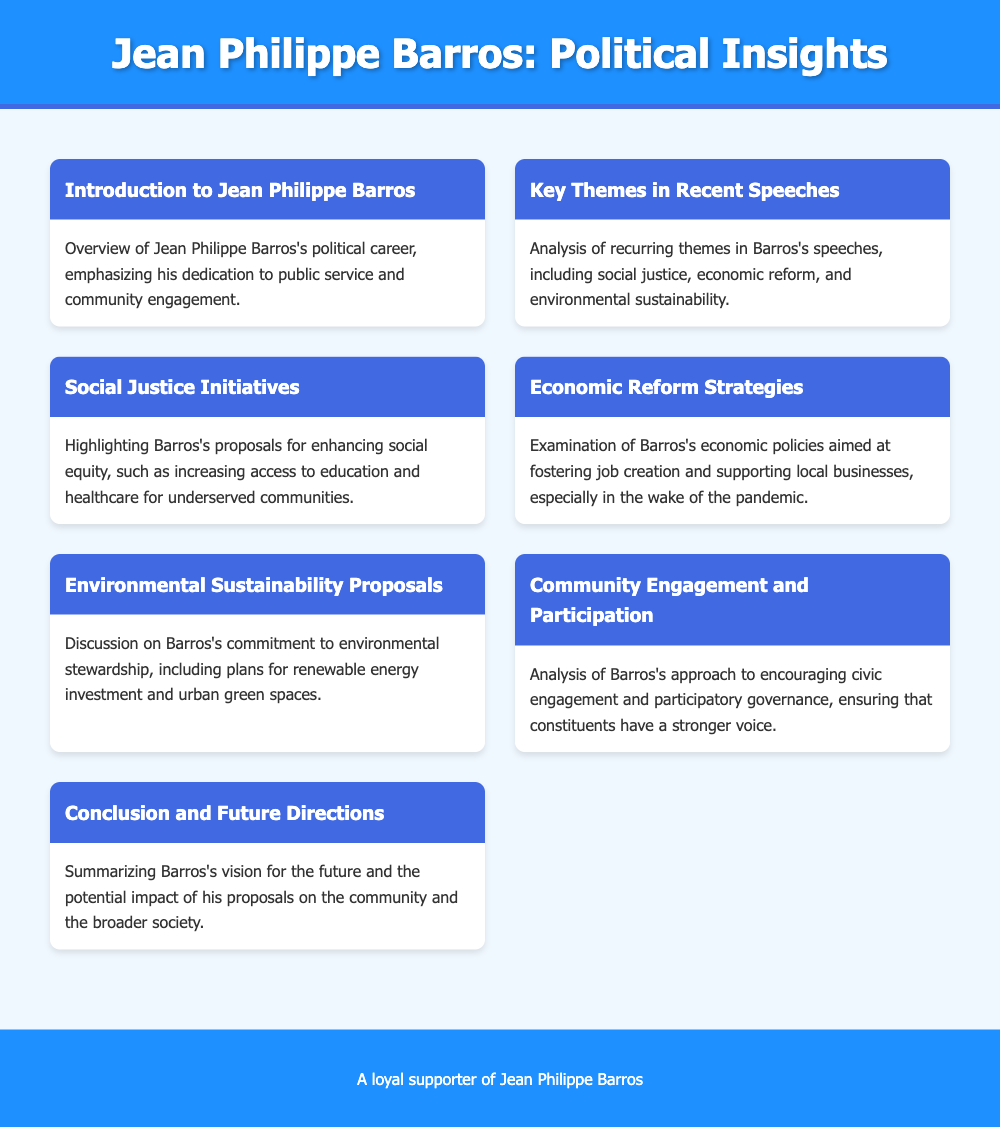What are the key themes in Barros's speeches? The document lists recurring themes such as social justice, economic reform, and environmental sustainability.
Answer: Social justice, economic reform, and environmental sustainability What does Barros propose for social equity? The document highlights proposals for increasing access to education and healthcare for underserved communities.
Answer: Increasing access to education and healthcare What is Barros's approach to community engagement? The document discusses Barros's strategies for encouraging civic engagement and participatory governance.
Answer: Encouraging civic engagement and participatory governance What are Barros's economic policies aimed at? The document examines Barros's economic policies focusing on job creation and supporting local businesses.
Answer: Job creation and supporting local businesses What future vision does Barros have? The document summarizes Barros's vision for the future and the impact of his proposals on the community.
Answer: Impact of his proposals on the community How does Barros plan to support environmental sustainability? The document mentions plans for renewable energy investment and urban green spaces as part of Barros's commitment.
Answer: Renewable energy investment and urban green spaces Who is the document about? The document is focused on the political insights related to Jean Philippe Barros.
Answer: Jean Philippe Barros What type of document is this? The document is structured as a menu of key insights regarding Jean Philippe Barros's political speeches and proposals.
Answer: A menu of key insights 